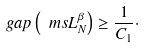<formula> <loc_0><loc_0><loc_500><loc_500>\ g a p \left ( \ m s L _ { N } ^ { \beta } \right ) \geq \frac { 1 } { C _ { 1 } } \cdot</formula> 